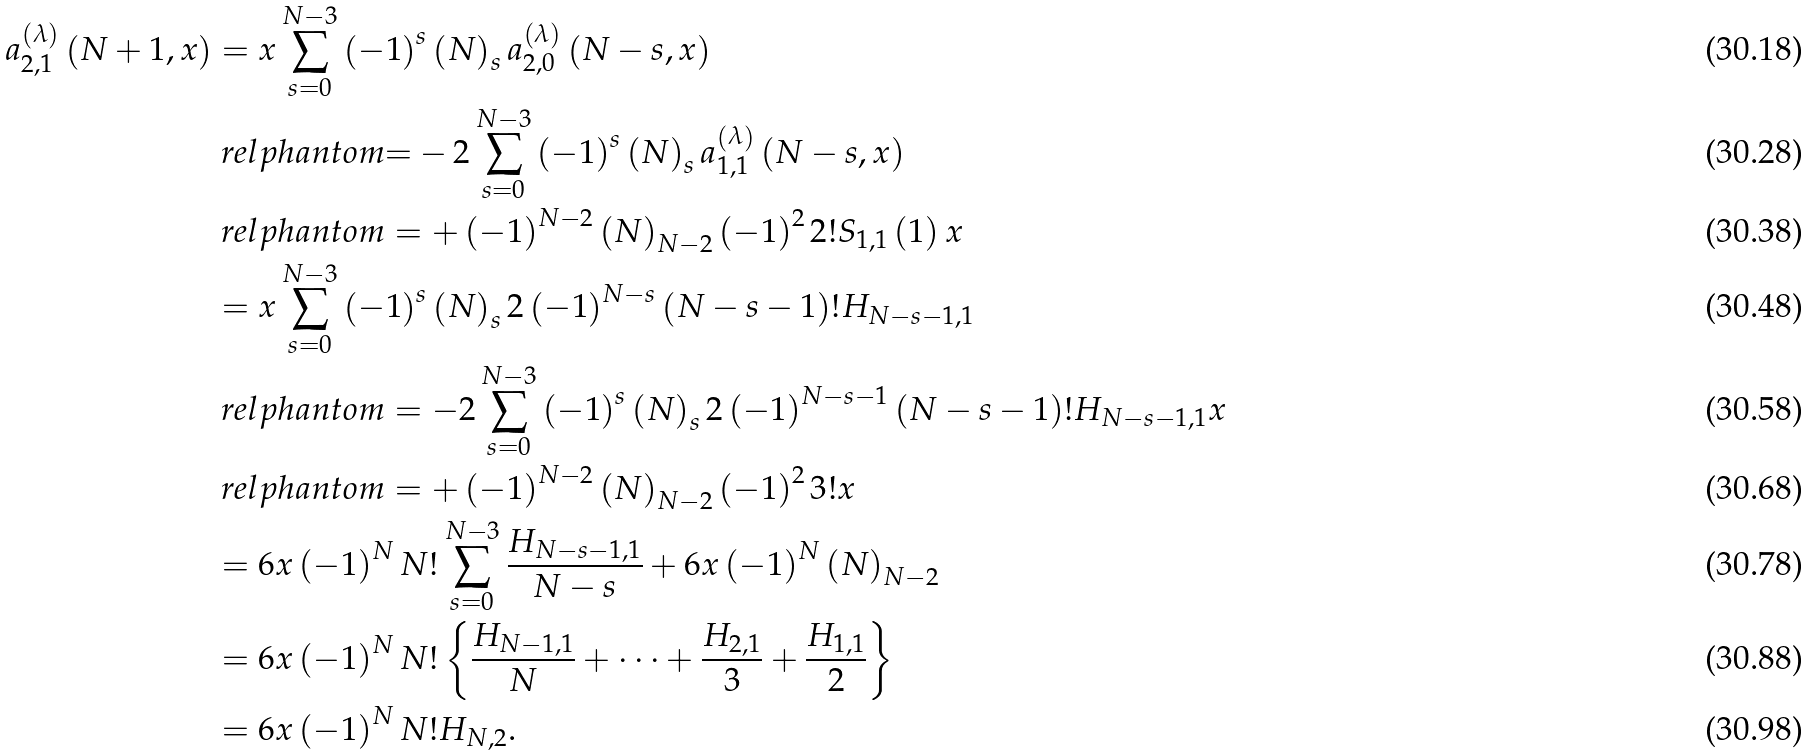Convert formula to latex. <formula><loc_0><loc_0><loc_500><loc_500>a _ { 2 , 1 } ^ { \left ( \lambda \right ) } \left ( N + 1 , x \right ) & = x \sum _ { s = 0 } ^ { N - 3 } \left ( - 1 \right ) ^ { s } \left ( N \right ) _ { s } a _ { 2 , 0 } ^ { \left ( \lambda \right ) } \left ( N - s , x \right ) \\ & \ r e l p h a n t o m { = } - 2 \sum _ { s = 0 } ^ { N - 3 } \left ( - 1 \right ) ^ { s } \left ( N \right ) _ { s } a _ { 1 , 1 } ^ { \left ( \lambda \right ) } \left ( N - s , x \right ) \\ & \ r e l p h a n t o m = + \left ( - 1 \right ) ^ { N - 2 } \left ( N \right ) _ { N - 2 } \left ( - 1 \right ) ^ { 2 } 2 ! S _ { 1 , 1 } \left ( 1 \right ) x \\ & = x \sum _ { s = 0 } ^ { N - 3 } \left ( - 1 \right ) ^ { s } \left ( N \right ) _ { s } 2 \left ( - 1 \right ) ^ { N - s } \left ( N - s - 1 \right ) ! H _ { N - s - 1 , 1 } \\ & \ r e l p h a n t o m = - 2 \sum _ { s = 0 } ^ { N - 3 } \left ( - 1 \right ) ^ { s } \left ( N \right ) _ { s } 2 \left ( - 1 \right ) ^ { N - s - 1 } \left ( N - s - 1 \right ) ! H _ { N - s - 1 , 1 } x \\ & \ r e l p h a n t o m = + \left ( - 1 \right ) ^ { N - 2 } \left ( N \right ) _ { N - 2 } \left ( - 1 \right ) ^ { 2 } 3 ! x \\ & = 6 x \left ( - 1 \right ) ^ { N } N ! \sum _ { s = 0 } ^ { N - 3 } \frac { H _ { N - s - 1 , 1 } } { N - s } + 6 x \left ( - 1 \right ) ^ { N } \left ( N \right ) _ { N - 2 } \\ & = 6 x \left ( - 1 \right ) ^ { N } N ! \left \{ \frac { H _ { N - 1 , 1 } } { N } + \cdots + \frac { H _ { 2 , 1 } } { 3 } + \frac { H _ { 1 , 1 } } { 2 } \right \} \\ & = 6 x \left ( - 1 \right ) ^ { N } N ! H _ { N , 2 } .</formula> 